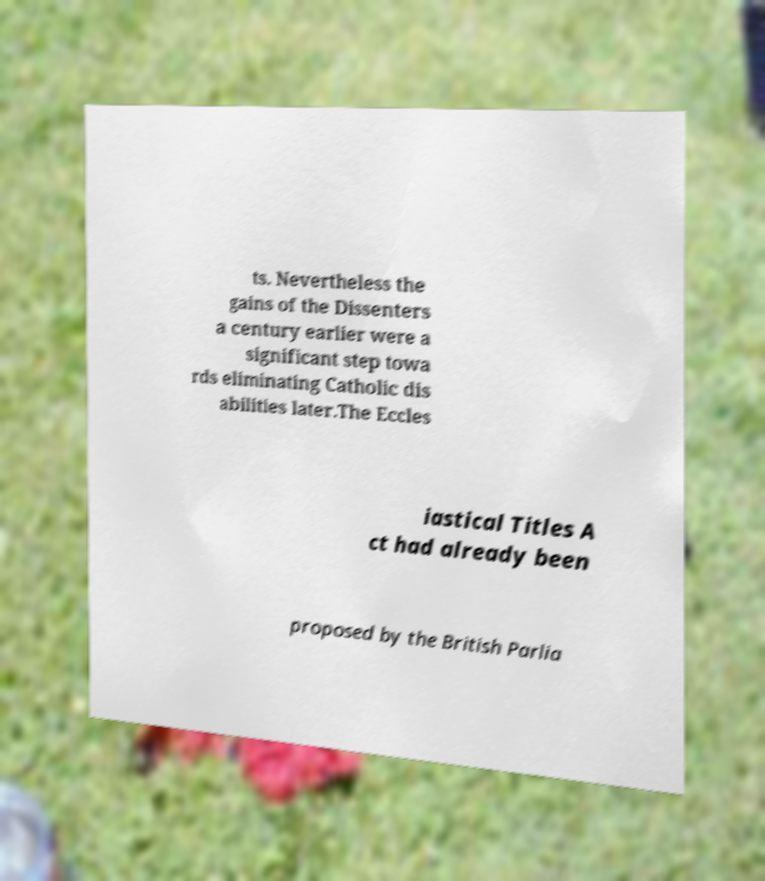Can you accurately transcribe the text from the provided image for me? ts. Nevertheless the gains of the Dissenters a century earlier were a significant step towa rds eliminating Catholic dis abilities later.The Eccles iastical Titles A ct had already been proposed by the British Parlia 